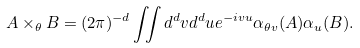Convert formula to latex. <formula><loc_0><loc_0><loc_500><loc_500>A \times _ { \theta } B = ( 2 \pi ) ^ { - d } \iint d ^ { d } v d ^ { d } u e ^ { - i v u } \alpha _ { \theta v } ( A ) \alpha _ { u } ( B ) .</formula> 